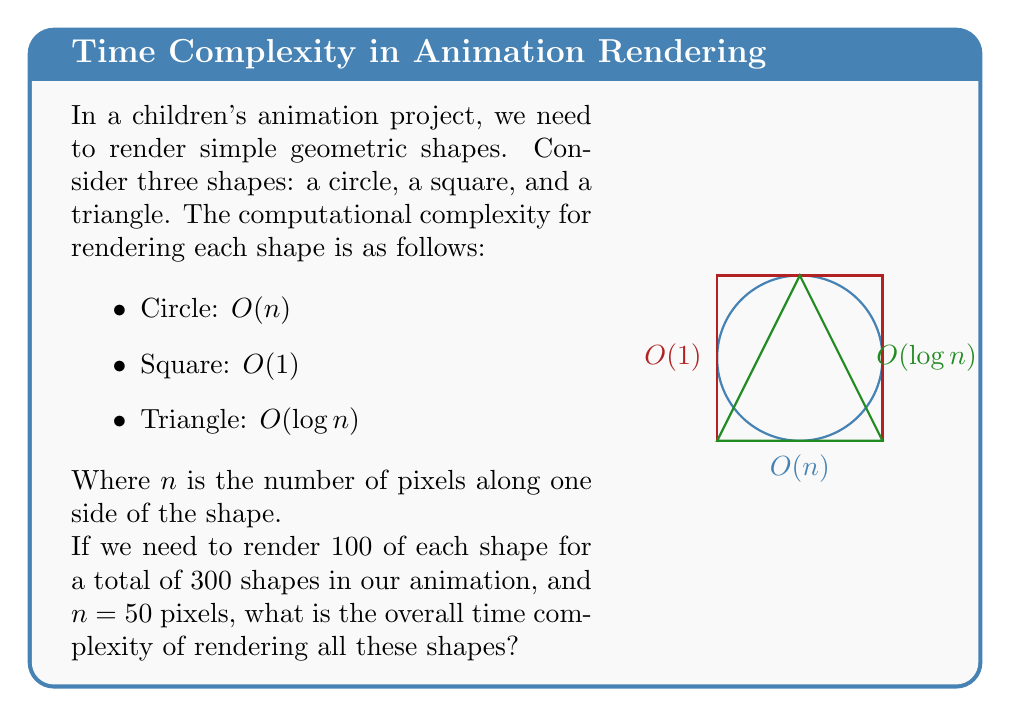Provide a solution to this math problem. Let's approach this step-by-step:

1) First, we need to calculate the time complexity for each shape type:

   - Circle: $O(n)$ for each circle, with 100 circles: $100 \cdot O(n) = O(100n) = O(n)$
   - Square: $O(1)$ for each square, with 100 squares: $100 \cdot O(1) = O(100) = O(1)$
   - Triangle: $O(\log n)$ for each triangle, with 100 triangles: $100 \cdot O(\log n) = O(100\log n) = O(\log n)$

2) Now, we need to combine these complexities. When we have different operations performed sequentially, we take the maximum of their complexities.

3) Therefore, the overall time complexity will be:

   $O(\max(n, 1, \log n))$

4) Since $n = 50$, we know that $n > \log n > 1$ for this value of $n$.

5) Thus, the maximum of these three terms is $n$.

Therefore, the overall time complexity is $O(n)$.
Answer: $O(n)$ 